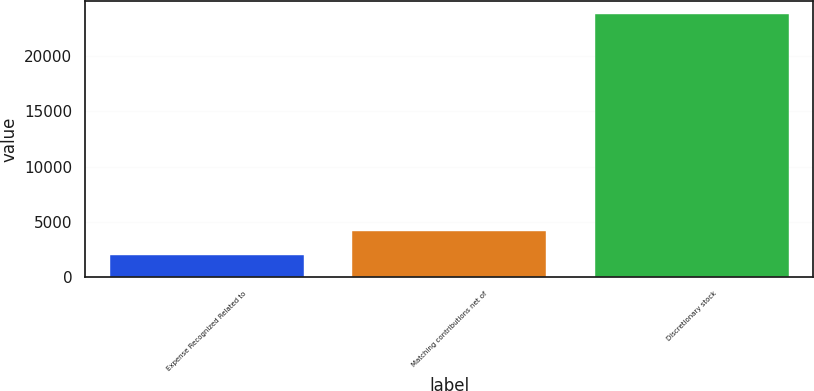Convert chart. <chart><loc_0><loc_0><loc_500><loc_500><bar_chart><fcel>Expense Recognized Related to<fcel>Matching contributions net of<fcel>Discretionary stock<nl><fcel>2012<fcel>4188<fcel>23772<nl></chart> 